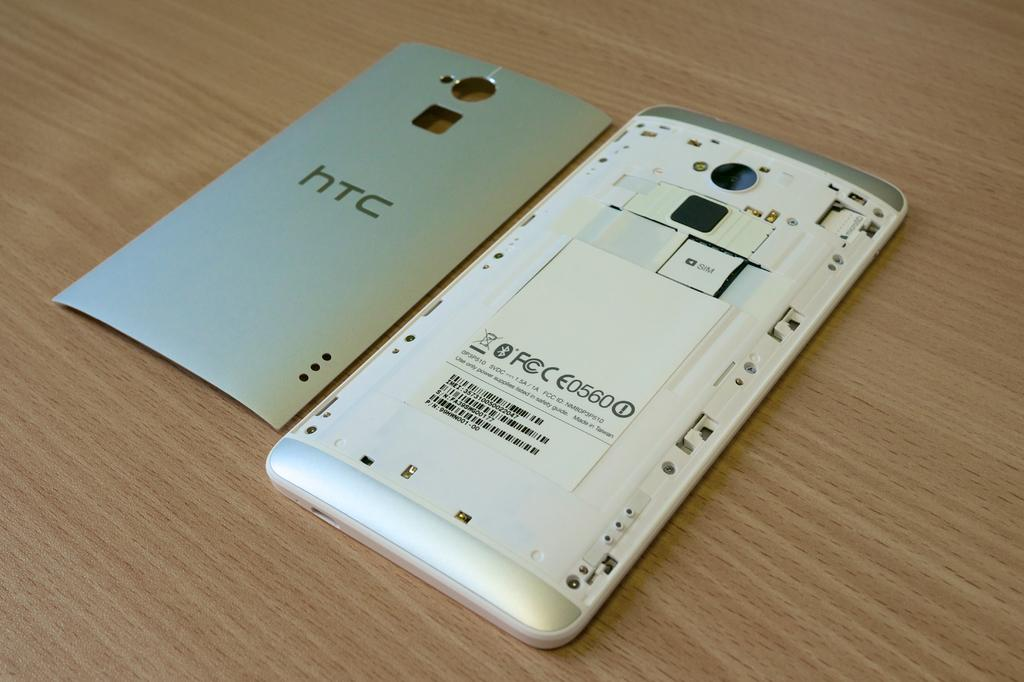Provide a one-sentence caption for the provided image. The back of a phone case showing a battery, the case says HTC. 